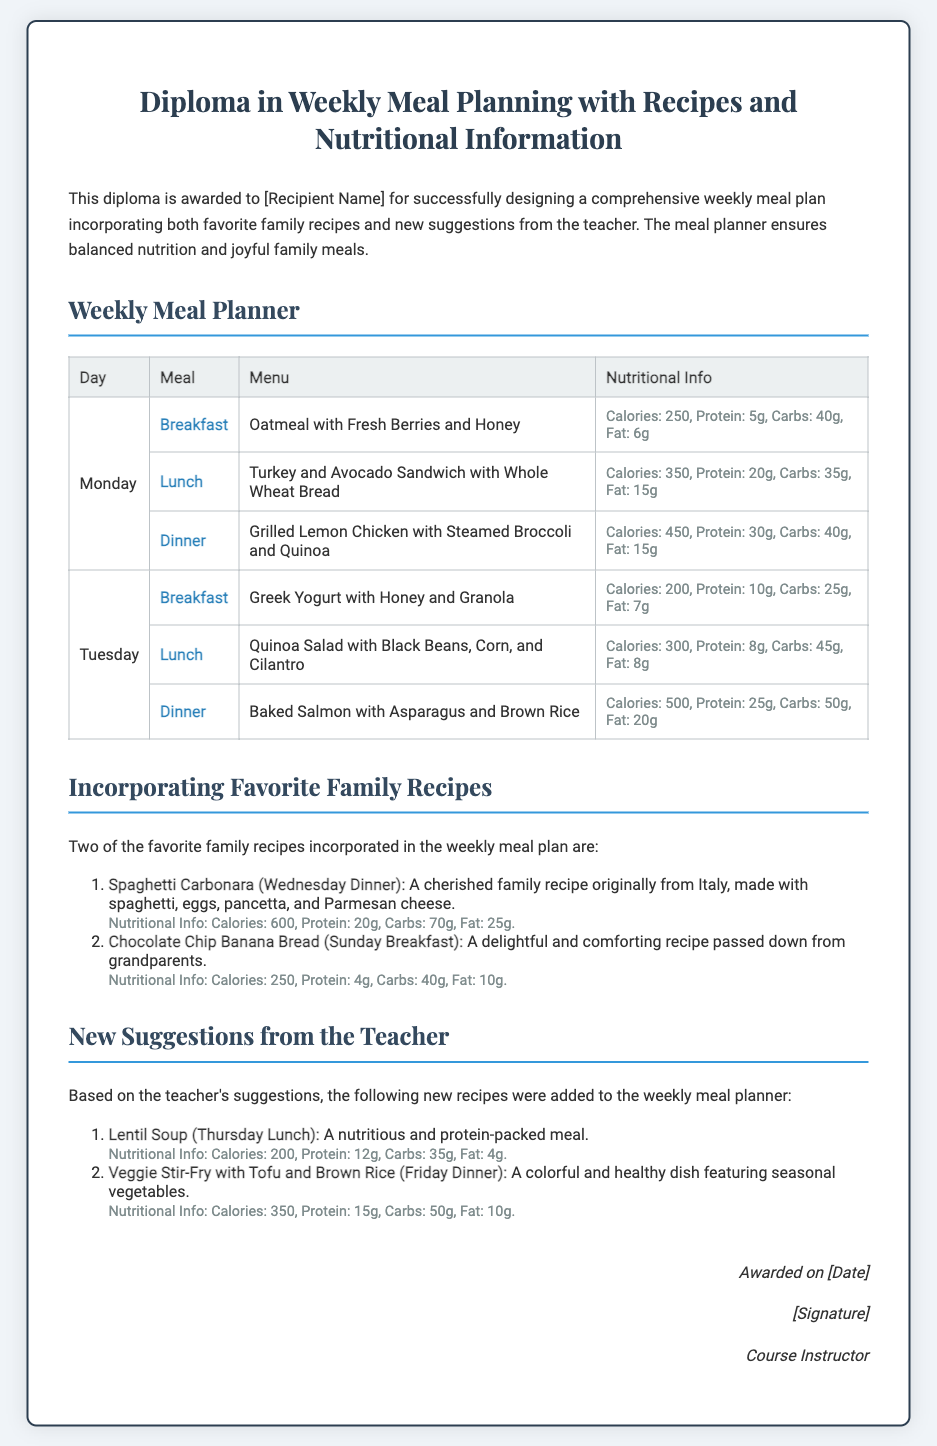What is the recipient's name? The document states that the diploma is awarded to "[Recipient Name]".
Answer: [Recipient Name] What is awarded for the diploma? The diploma is awarded for successfully designing a comprehensive weekly meal plan.
Answer: Weekly meal plan What is the breakfast menu for Tuesday? The breakfast for Tuesday includes "Greek Yogurt with Honey and Granola".
Answer: Greek Yogurt with Honey and Granola How many grams of protein are in Monday's lunch? The nutritional information in Monday's lunch states that it contains "20g" of protein.
Answer: 20g What is the nutritional information for Spaghetti Carbonara? The document provides that Spaghetti Carbonara has "Calories: 600, Protein: 20g, Carbs: 70g, Fat: 25g."
Answer: Calories: 600, Protein: 20g, Carbs: 70g, Fat: 25g Which new recipe was added for Thursday lunch? The new recipe added for Thursday lunch is "Lentil Soup."
Answer: Lentil Soup What is the course instructor's title? The title mentioned for the person who awarded the diploma is "Course Instructor."
Answer: Course Instructor What day features the most favorite family recipes? The favorite family recipes featured in the document include a recipe for Wednesday and Sunday, but there are two equal mentions, so both can be considered.
Answer: Wednesday and Sunday What is the main ingredient in the Veggie Stir-Fry recipe? The Veggie Stir-Fry is highlighted to include "Tofu".
Answer: Tofu 